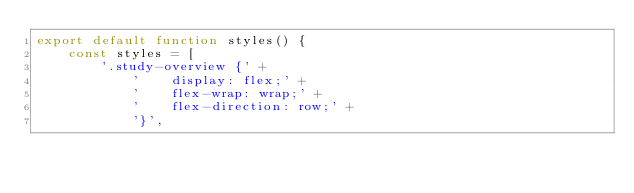Convert code to text. <code><loc_0><loc_0><loc_500><loc_500><_JavaScript_>export default function styles() {
    const styles = [
        '.study-overview {' +
            '    display: flex;' +
            '    flex-wrap: wrap;' +
            '    flex-direction: row;' +
            '}',</code> 